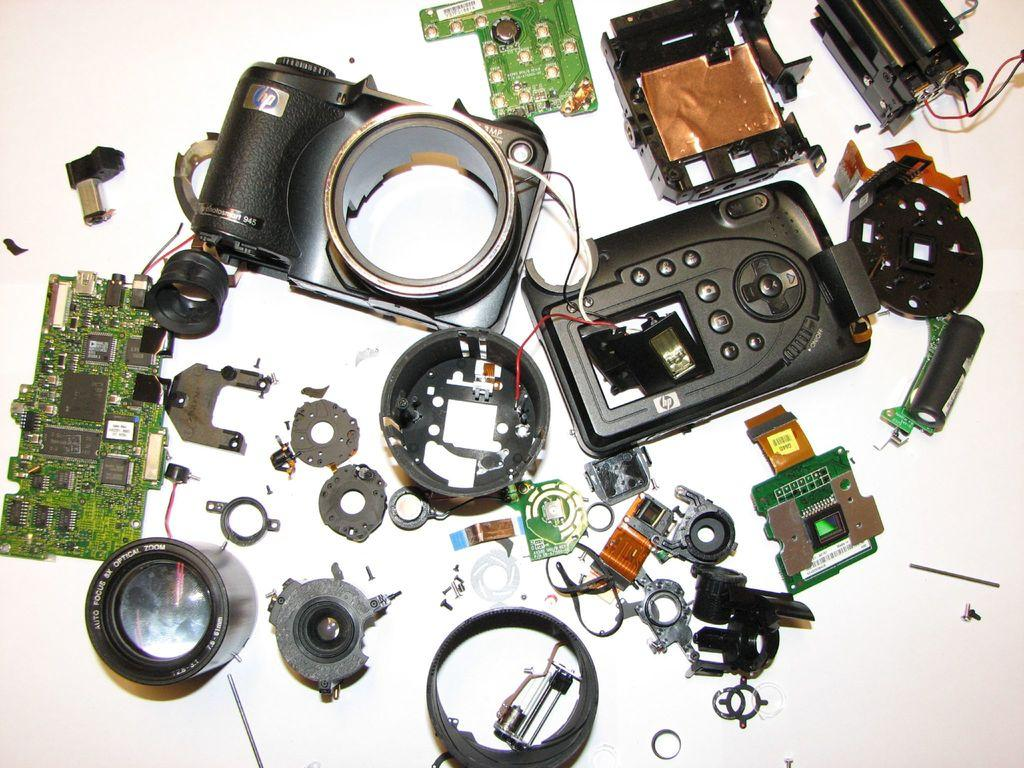What type of object is depicted in the image? The image contains parts of a camera. Where are the parts of the camera located? The parts of the camera are on a table. What type of approval is required to use the pail in the image? There is no pail present in the image, so no approval is required. 